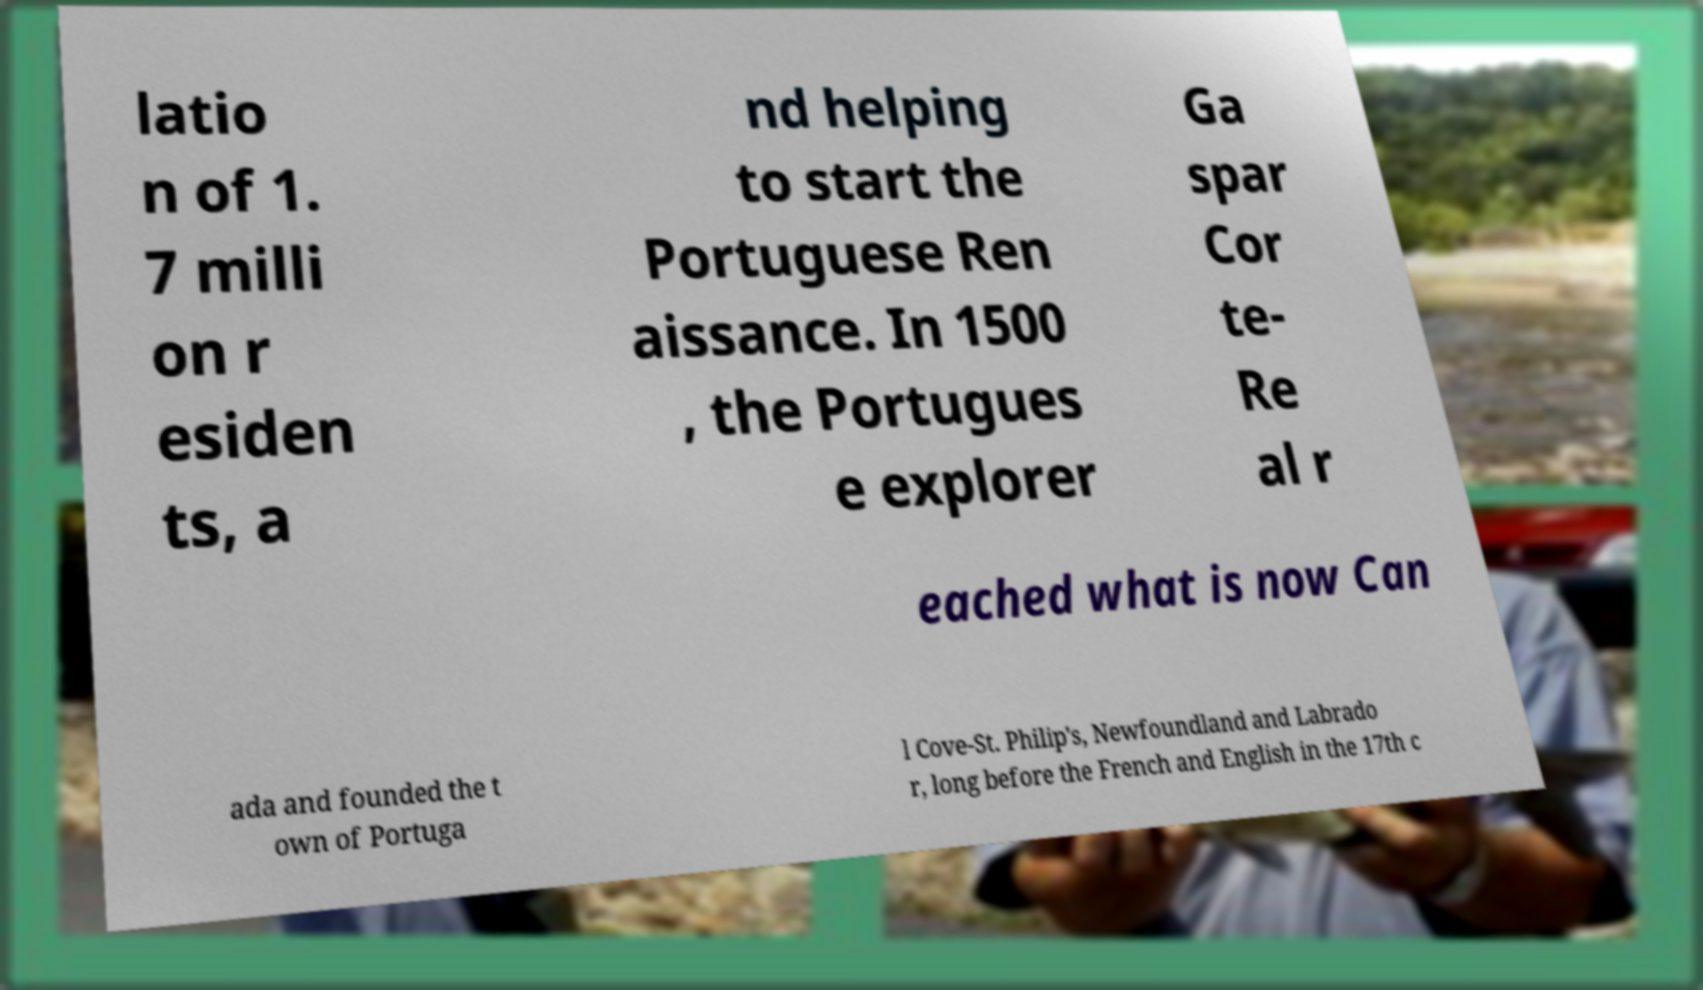Could you extract and type out the text from this image? latio n of 1. 7 milli on r esiden ts, a nd helping to start the Portuguese Ren aissance. In 1500 , the Portugues e explorer Ga spar Cor te- Re al r eached what is now Can ada and founded the t own of Portuga l Cove-St. Philip's, Newfoundland and Labrado r, long before the French and English in the 17th c 